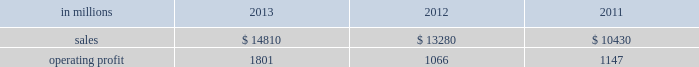Areas exceeding 14.1 million acres ( 5.7 million hectares ) .
Products and brand designations appearing in italics are trademarks of international paper or a related company .
Industry segment results industrial packaging demand for industrial packaging products is closely correlated with non-durable industrial goods production , as well as with demand for processed foods , poultry , meat and agricultural products .
In addition to prices and volumes , major factors affecting the profitability of industrial packaging are raw material and energy costs , freight costs , manufacturing efficiency and product mix .
Industrial packaging net sales and operating profits include the results of the temple-inland packaging operations from the date of acquisition in february 2012 and the results of the brazil packaging business from the date of acquisition in january 2013 .
In addition , due to the acquisition of a majority share of olmuksa international paper sabanci ambalaj sanayi ve ticaret a.s. , ( now called olmuksan international paper or olmuksan ) net sales for our corrugated packaging business in turkey are included in the business segment totals beginning in the first quarter of 2013 and the operating profits reflect a higher ownership percentage than in previous years .
Net sales for 2013 increased 12% ( 12 % ) to $ 14.8 billion compared with $ 13.3 billion in 2012 , and 42% ( 42 % ) compared with $ 10.4 billion in 2011 .
Operating profits were 69% ( 69 % ) higher in 2013 than in 2012 and 57% ( 57 % ) higher than in 2011 .
Excluding costs associated with the acquisition and integration of temple-inland , the divestiture of three containerboard mills and other special items , operating profits in 2013 were 36% ( 36 % ) higher than in 2012 and 59% ( 59 % ) higher than in 2011 .
Benefits from the net impact of higher average sales price realizations and an unfavorable mix ( $ 749 million ) were offset by lower sales volumes ( $ 73 million ) , higher operating costs ( $ 64 million ) , higher maintenance outage costs ( $ 16 million ) and higher input costs ( $ 102 million ) .
Additionally , operating profits in 2013 include costs of $ 62 million associated with the integration of temple-inland , a gain of $ 13 million related to a bargain purchase adjustment on the acquisition of a majority share of our operations in turkey , and a net gain of $ 1 million for other items , while operating profits in 2012 included costs of $ 184 million associated with the acquisition and integration of temple-inland , mill divestiture costs of $ 91 million , costs associated with the restructuring of our european packaging business of $ 17 million and a $ 3 million gain for other items .
Industrial packaging .
North american industrial packaging net sales were $ 12.5 billion in 2013 compared with $ 11.6 billion in 2012 and $ 8.6 billion in 2011 .
Operating profits in 2013 were $ 1.8 billion ( both including and excluding costs associated with the integration of temple-inland and other special items ) compared with $ 1.0 billion ( $ 1.3 billion excluding costs associated with the acquisition and integration of temple-inland and mill divestiture costs ) in 2012 and $ 1.1 billion ( both including and excluding costs associated with signing an agreement to acquire temple-inland ) in 2011 .
Sales volumes decreased in 2013 compared with 2012 reflecting flat demand for boxes and the impact of commercial decisions .
Average sales price realizations were significantly higher mainly due to the realization of price increases for domestic containerboard and boxes .
Input costs were higher for wood , energy and recycled fiber .
Freight costs also increased .
Planned maintenance downtime costs were higher than in 2012 .
Manufacturing operating costs decreased , but were offset by inflation and higher overhead and distribution costs .
The business took about 850000 tons of total downtime in 2013 of which about 450000 were market- related and 400000 were maintenance downtime .
In 2012 , the business took about 945000 tons of total downtime of which about 580000 were market-related and about 365000 were maintenance downtime .
Operating profits in 2013 included $ 62 million of costs associated with the integration of temple-inland .
Operating profits in 2012 included $ 184 million of costs associated with the acquisition and integration of temple-inland and $ 91 million of costs associated with the divestiture of three containerboard mills .
Looking ahead to 2014 , compared with the fourth quarter of 2013 , sales volumes in the first quarter are expected to increase for boxes due to a higher number of shipping days offset by the impact from the severe winter weather events impacting much of the u.s .
Input costs are expected to be higher for energy , recycled fiber , wood and starch .
Planned maintenance downtime spending is expected to be about $ 51 million higher with outages scheduled at six mills compared with four mills in the 2013 fourth quarter .
Manufacturing operating costs are expected to be lower .
However , operating profits will be negatively impacted by the adverse winter weather in the first quarter of 2014 .
Emea industrial packaging net sales in 2013 include the sales of our packaging operations in turkey which are now fully consolidated .
Net sales were $ 1.3 billion in 2013 compared with $ 1.0 billion in 2012 and $ 1.1 billion in 2011 .
Operating profits in 2013 were $ 43 million ( $ 32 .
What was the increase in net sales in billions in 2013? 
Computations: (14.8 * 12%)
Answer: 1.776. 